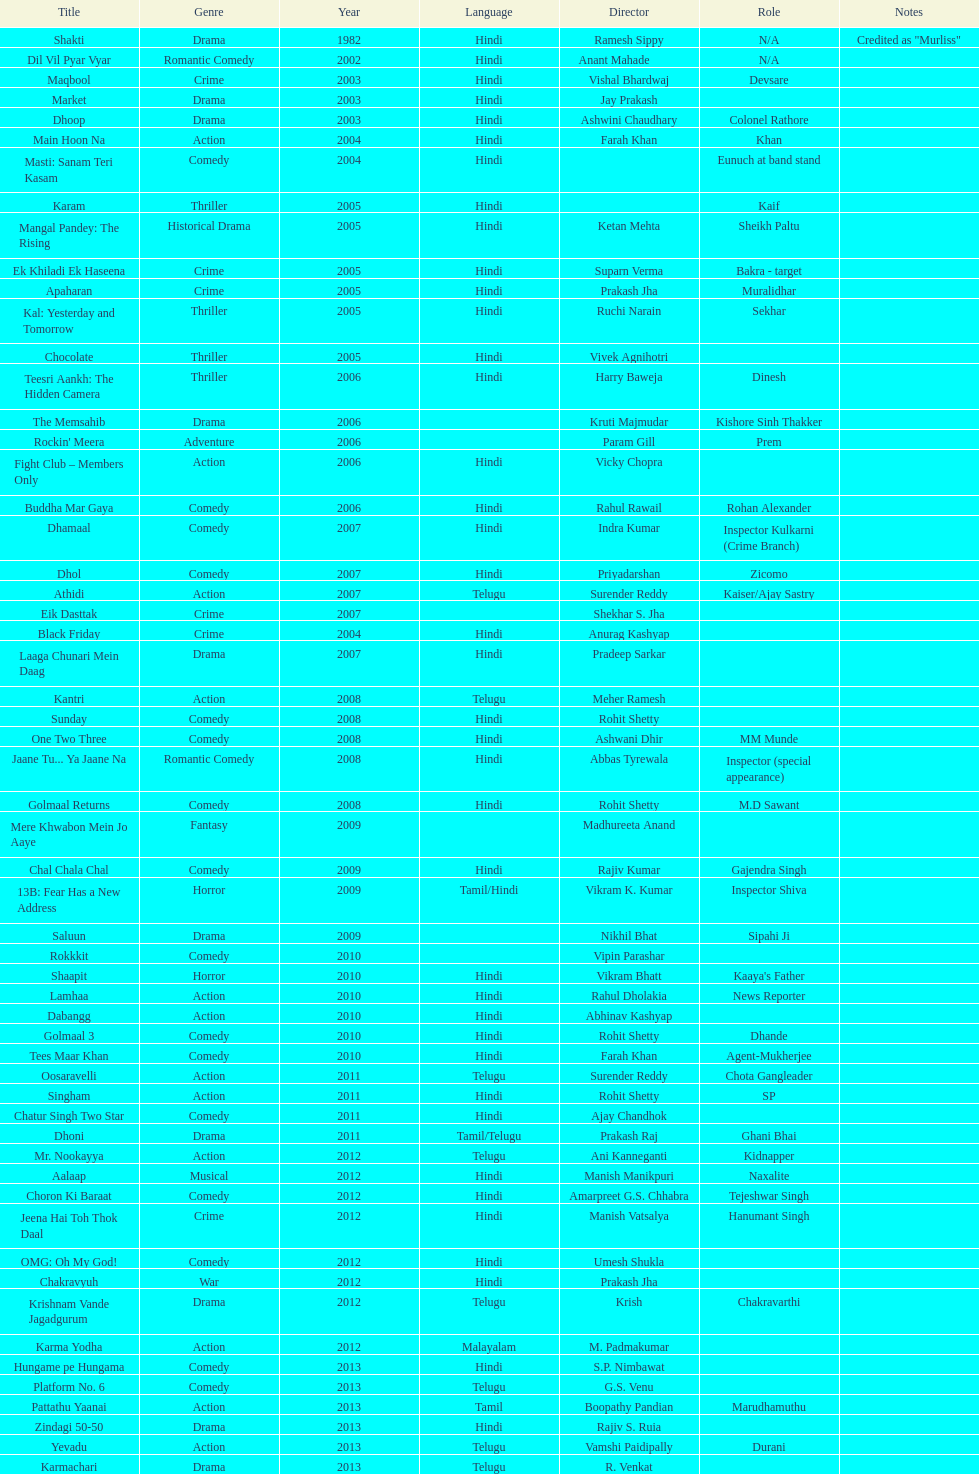What is the total years on the chart 13. 